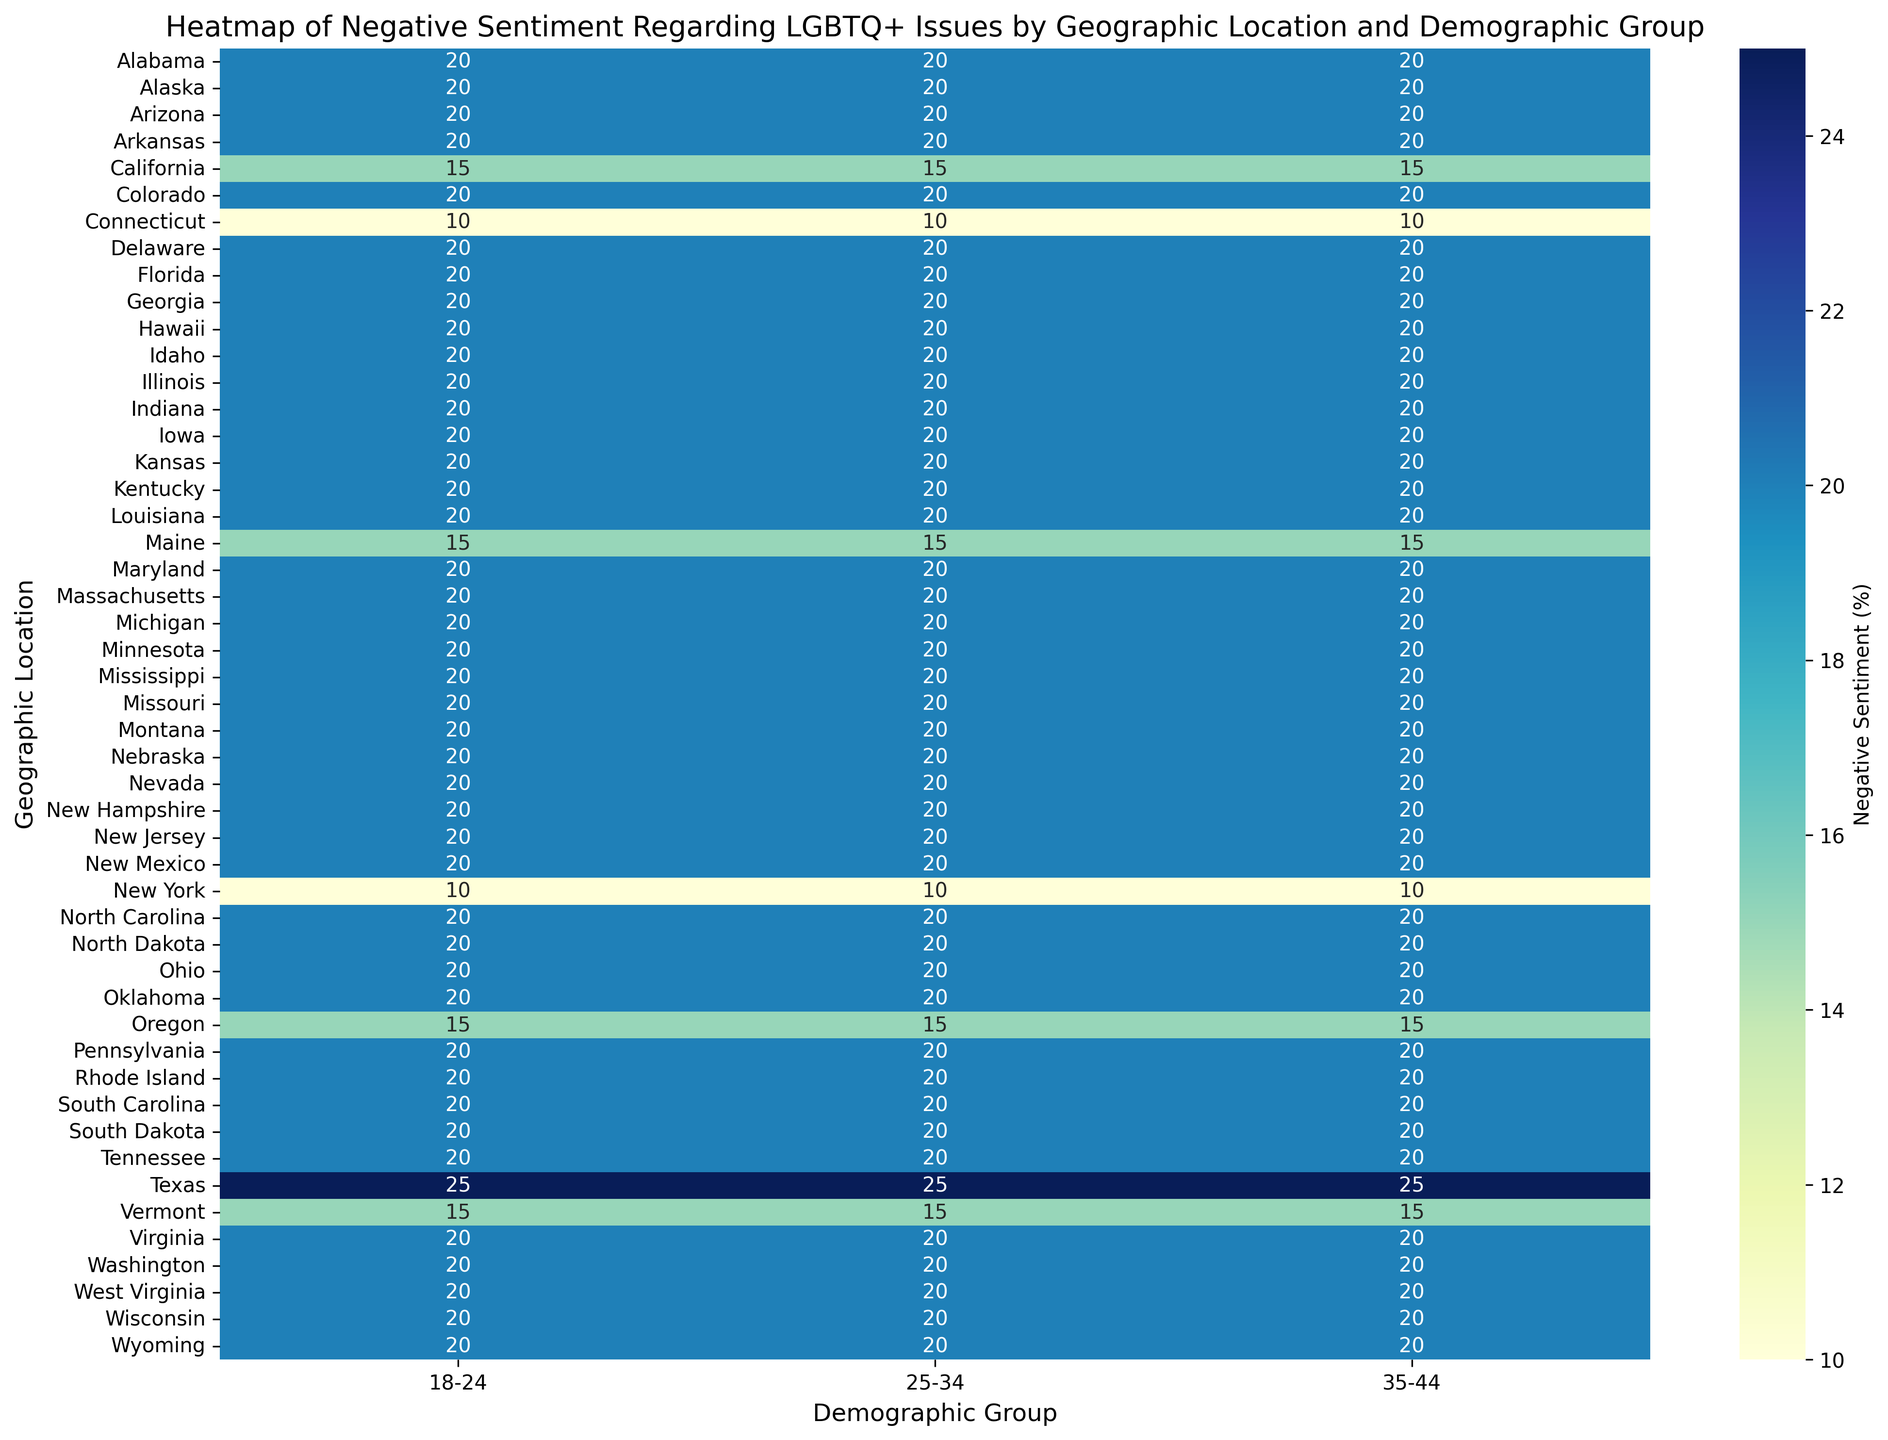What geographic location has the highest negative sentiment for the 35-44 age group? To determine the geographic location with the highest negative sentiment for the 35-44 age group, look at the value in the heatmap cells located at the intersection of the 35-44 column and each geographic location row. Identify the highest number.
Answer: Wyoming (50%) Does the 25-34 age group in California have a higher negative sentiment than the 25-34 age group in Texas? Compare the values in the heatmap for the 25-34 age group between California and Texas. Look at the corresponding cells in the 25-34 column for both locations.
Answer: No Which demographic group in Connecticut has the lowest negative sentiment? To find the demographic group with the lowest negative sentiment in Connecticut, find the smallest value across the 18-24, 25-34, and 35-44 columns for Connecticut.
Answer: 18-24 (10%) Compare the negative sentiments of the 35-44 age group in Oregon and Florida. Which state has a lower negative sentiment? Look at the values in the heatmap for the 35-44 age group in both Oregon and Florida. Compare these values to determine which one is lower.
Answer: Oregon What is the average negative sentiment for Maine across all demographic groups? Calculate the average by summing the negative sentiments for the 18-24, 25-34, and 35-44 age groups in Maine, then divide by the number of groups. (15 + 15 + 15) / 3 = 15
Answer: 15% Is the negative sentiment in the 18-24 age group in any state higher than the negative sentiment in the 35-44 age group in Alabama? Compare the negative sentiment value for the 18-24 age group in all states with the value for the 35-44 age group in Alabama. The value for the 35-44 age group in Alabama is 20.
Answer: No What is the total negative sentiment for the 25-34 age group in Texas, Florida, and New York combined? Add the negative sentiment values for the 25-34 age group in Texas, Florida, and New York. (25 + 20 + 10) = 55
Answer: 55% Which state shows the most consistent negative sentiment across all three demographic groups? Consistency can be checked by seeing which state has the smallest range between its highest and lowest values in the 18-24, 25-34, and 35-44 columns.
Answer: California or Oregon or Maine What visual pattern or trend can you identify about the negative sentiment as age increases across the states? Observe the color gradient in the heatmap across the 18-24, 25-34, and 35-44 columns for most states to identify any trends. Typically, a trend is noticeable if there's a consistent change in color intensity from one age group to the next as age increases.
Answer: Varies, but some states show an increase Which geographic location has a significant spike in negative sentiment for the 25-34 age group compared to other age groups? Look for a location where the cell in the 25-34 column is much darker (indicating higher negative sentiment) compared to the cells in the 18-24 and 35-44 columns.
Answer: Alabama and Wyoming 